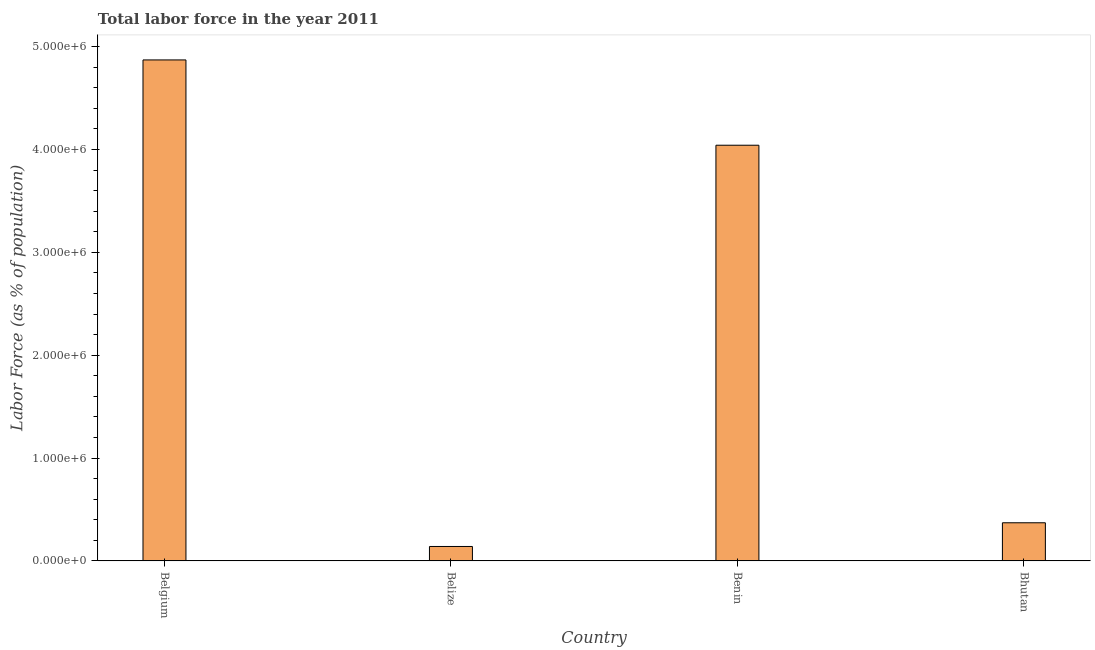What is the title of the graph?
Keep it short and to the point. Total labor force in the year 2011. What is the label or title of the Y-axis?
Give a very brief answer. Labor Force (as % of population). What is the total labor force in Bhutan?
Make the answer very short. 3.71e+05. Across all countries, what is the maximum total labor force?
Offer a very short reply. 4.87e+06. Across all countries, what is the minimum total labor force?
Keep it short and to the point. 1.40e+05. In which country was the total labor force maximum?
Give a very brief answer. Belgium. In which country was the total labor force minimum?
Offer a very short reply. Belize. What is the sum of the total labor force?
Provide a succinct answer. 9.42e+06. What is the difference between the total labor force in Belize and Benin?
Ensure brevity in your answer.  -3.90e+06. What is the average total labor force per country?
Make the answer very short. 2.36e+06. What is the median total labor force?
Ensure brevity in your answer.  2.21e+06. In how many countries, is the total labor force greater than 400000 %?
Provide a short and direct response. 2. What is the ratio of the total labor force in Belize to that in Bhutan?
Ensure brevity in your answer.  0.38. What is the difference between the highest and the second highest total labor force?
Keep it short and to the point. 8.29e+05. Is the sum of the total labor force in Belize and Benin greater than the maximum total labor force across all countries?
Your response must be concise. No. What is the difference between the highest and the lowest total labor force?
Give a very brief answer. 4.73e+06. How many bars are there?
Make the answer very short. 4. Are all the bars in the graph horizontal?
Your response must be concise. No. Are the values on the major ticks of Y-axis written in scientific E-notation?
Give a very brief answer. Yes. What is the Labor Force (as % of population) in Belgium?
Give a very brief answer. 4.87e+06. What is the Labor Force (as % of population) in Belize?
Provide a short and direct response. 1.40e+05. What is the Labor Force (as % of population) in Benin?
Your answer should be compact. 4.04e+06. What is the Labor Force (as % of population) in Bhutan?
Your response must be concise. 3.71e+05. What is the difference between the Labor Force (as % of population) in Belgium and Belize?
Provide a succinct answer. 4.73e+06. What is the difference between the Labor Force (as % of population) in Belgium and Benin?
Offer a terse response. 8.29e+05. What is the difference between the Labor Force (as % of population) in Belgium and Bhutan?
Your response must be concise. 4.50e+06. What is the difference between the Labor Force (as % of population) in Belize and Benin?
Your response must be concise. -3.90e+06. What is the difference between the Labor Force (as % of population) in Belize and Bhutan?
Make the answer very short. -2.30e+05. What is the difference between the Labor Force (as % of population) in Benin and Bhutan?
Offer a very short reply. 3.67e+06. What is the ratio of the Labor Force (as % of population) in Belgium to that in Belize?
Provide a short and direct response. 34.75. What is the ratio of the Labor Force (as % of population) in Belgium to that in Benin?
Your response must be concise. 1.21. What is the ratio of the Labor Force (as % of population) in Belgium to that in Bhutan?
Ensure brevity in your answer.  13.14. What is the ratio of the Labor Force (as % of population) in Belize to that in Benin?
Your response must be concise. 0.04. What is the ratio of the Labor Force (as % of population) in Belize to that in Bhutan?
Your answer should be very brief. 0.38. What is the ratio of the Labor Force (as % of population) in Benin to that in Bhutan?
Offer a very short reply. 10.9. 